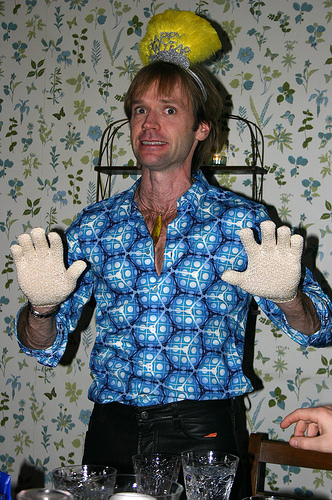<image>
Can you confirm if the man is in front of the glass? No. The man is not in front of the glass. The spatial positioning shows a different relationship between these objects. 